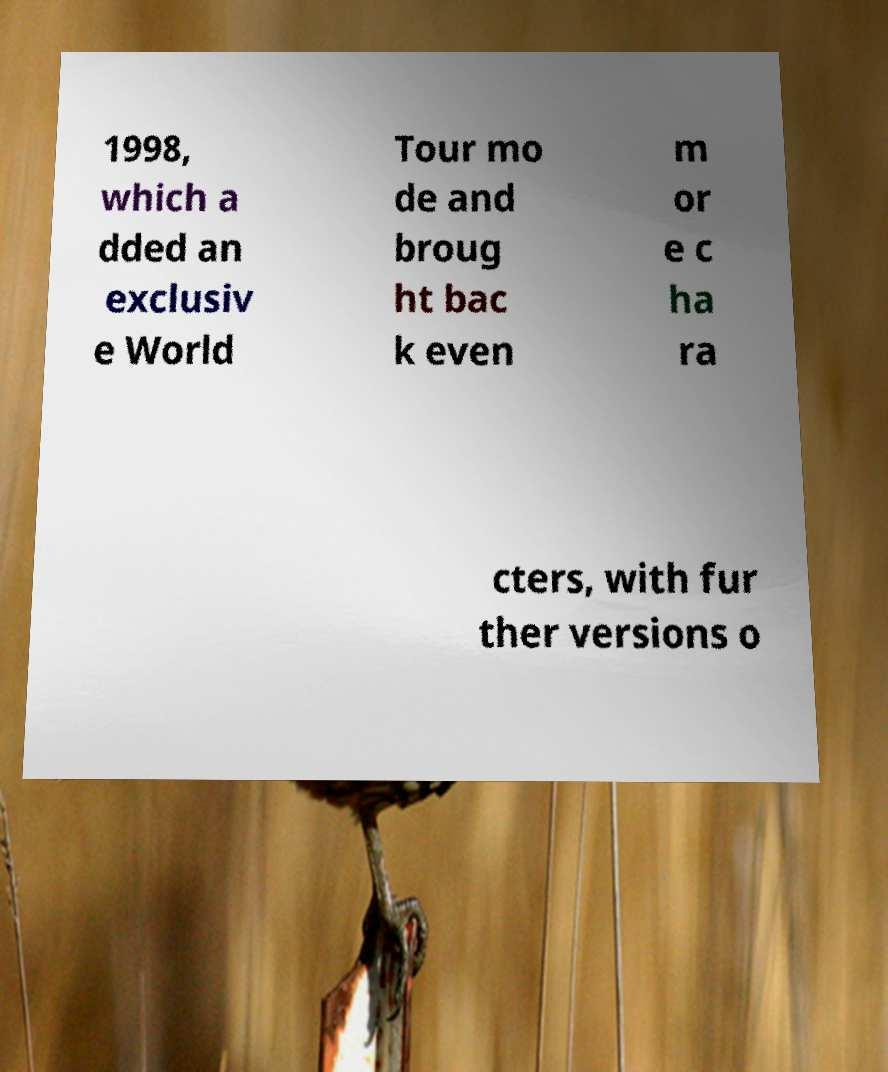There's text embedded in this image that I need extracted. Can you transcribe it verbatim? 1998, which a dded an exclusiv e World Tour mo de and broug ht bac k even m or e c ha ra cters, with fur ther versions o 